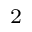<formula> <loc_0><loc_0><loc_500><loc_500>^ { 2 }</formula> 